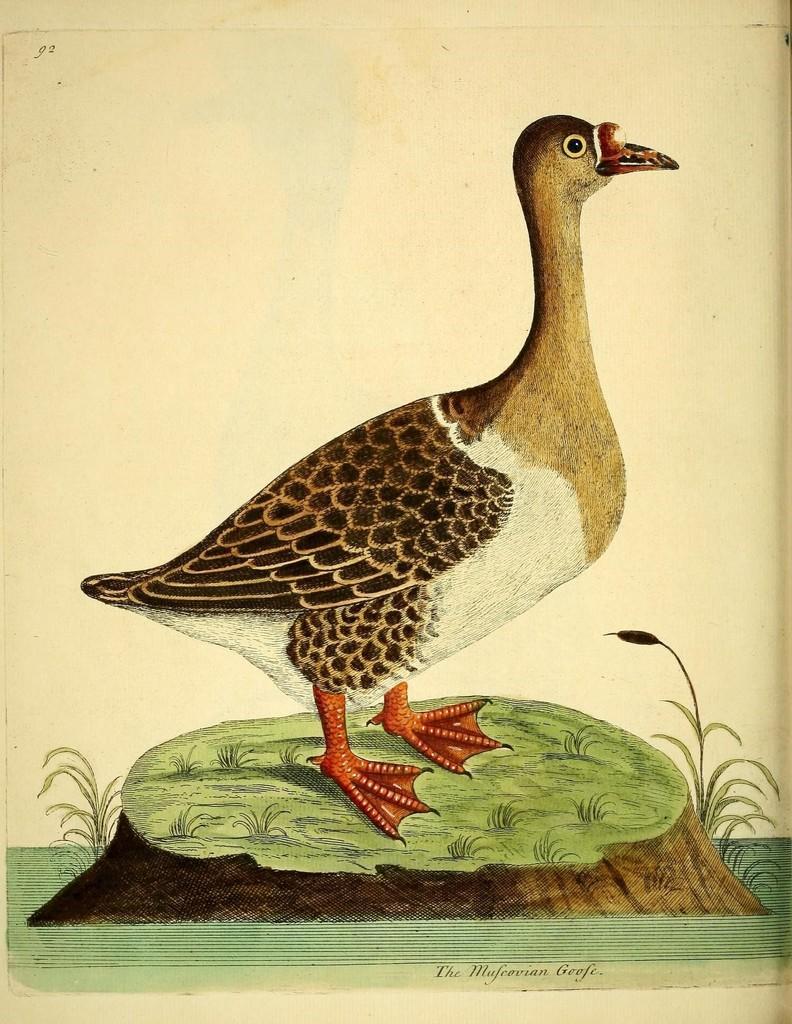Could you give a brief overview of what you see in this image? This is a painting. In this picture can see a bird standing on a green surface. We can see some grass on a wooden object. There are a few plants visible on both sides of a wooden object. We can see some text on top and at the bottom of the picture. There is a creamy background. 